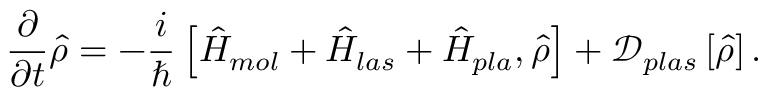<formula> <loc_0><loc_0><loc_500><loc_500>\frac { \partial } { \partial t } \hat { \rho } = - \frac { i } { } \left [ \hat { H } _ { m o l } + \hat { H } _ { l a s } + \hat { H } _ { p l a } , \hat { \rho } \right ] + \mathcal { D } _ { p l a s } \left [ \hat { \rho } \right ] .</formula> 